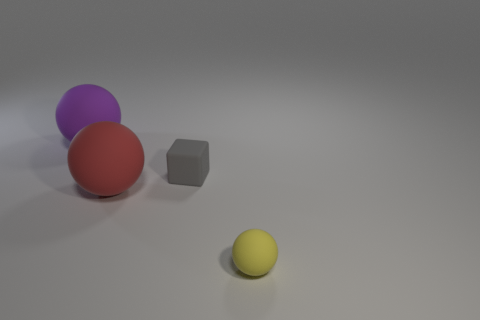What material is the sphere that is the same size as the block? rubber 